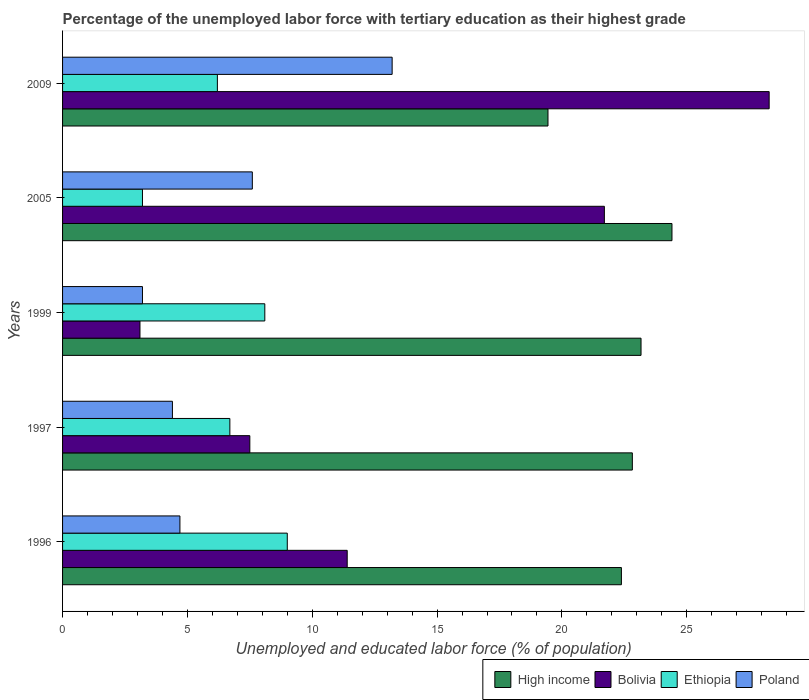Are the number of bars on each tick of the Y-axis equal?
Your response must be concise. Yes. How many bars are there on the 1st tick from the top?
Your answer should be very brief. 4. What is the percentage of the unemployed labor force with tertiary education in Bolivia in 1997?
Your response must be concise. 7.5. Across all years, what is the maximum percentage of the unemployed labor force with tertiary education in Bolivia?
Your answer should be compact. 28.3. Across all years, what is the minimum percentage of the unemployed labor force with tertiary education in Ethiopia?
Provide a succinct answer. 3.2. In which year was the percentage of the unemployed labor force with tertiary education in Ethiopia maximum?
Offer a terse response. 1996. What is the total percentage of the unemployed labor force with tertiary education in Ethiopia in the graph?
Give a very brief answer. 33.2. What is the difference between the percentage of the unemployed labor force with tertiary education in Poland in 1996 and that in 2005?
Your response must be concise. -2.9. What is the difference between the percentage of the unemployed labor force with tertiary education in Poland in 2005 and the percentage of the unemployed labor force with tertiary education in Bolivia in 1997?
Offer a terse response. 0.1. What is the average percentage of the unemployed labor force with tertiary education in Poland per year?
Provide a succinct answer. 6.62. In the year 1997, what is the difference between the percentage of the unemployed labor force with tertiary education in Bolivia and percentage of the unemployed labor force with tertiary education in Poland?
Offer a very short reply. 3.1. In how many years, is the percentage of the unemployed labor force with tertiary education in Poland greater than 6 %?
Offer a terse response. 2. What is the ratio of the percentage of the unemployed labor force with tertiary education in Bolivia in 1996 to that in 1997?
Offer a terse response. 1.52. Is the difference between the percentage of the unemployed labor force with tertiary education in Bolivia in 1996 and 2009 greater than the difference between the percentage of the unemployed labor force with tertiary education in Poland in 1996 and 2009?
Your answer should be very brief. No. What is the difference between the highest and the second highest percentage of the unemployed labor force with tertiary education in Bolivia?
Your answer should be compact. 6.6. What is the difference between the highest and the lowest percentage of the unemployed labor force with tertiary education in Poland?
Provide a succinct answer. 10. Is the sum of the percentage of the unemployed labor force with tertiary education in Poland in 1996 and 1997 greater than the maximum percentage of the unemployed labor force with tertiary education in High income across all years?
Your answer should be compact. No. What does the 2nd bar from the bottom in 2005 represents?
Keep it short and to the point. Bolivia. Is it the case that in every year, the sum of the percentage of the unemployed labor force with tertiary education in Poland and percentage of the unemployed labor force with tertiary education in High income is greater than the percentage of the unemployed labor force with tertiary education in Bolivia?
Provide a succinct answer. Yes. How many bars are there?
Keep it short and to the point. 20. Are the values on the major ticks of X-axis written in scientific E-notation?
Provide a short and direct response. No. Does the graph contain grids?
Keep it short and to the point. No. Where does the legend appear in the graph?
Offer a very short reply. Bottom right. How many legend labels are there?
Ensure brevity in your answer.  4. What is the title of the graph?
Make the answer very short. Percentage of the unemployed labor force with tertiary education as their highest grade. What is the label or title of the X-axis?
Give a very brief answer. Unemployed and educated labor force (% of population). What is the label or title of the Y-axis?
Your answer should be very brief. Years. What is the Unemployed and educated labor force (% of population) of High income in 1996?
Your response must be concise. 22.38. What is the Unemployed and educated labor force (% of population) in Bolivia in 1996?
Make the answer very short. 11.4. What is the Unemployed and educated labor force (% of population) of Poland in 1996?
Provide a succinct answer. 4.7. What is the Unemployed and educated labor force (% of population) of High income in 1997?
Provide a short and direct response. 22.82. What is the Unemployed and educated labor force (% of population) of Bolivia in 1997?
Provide a succinct answer. 7.5. What is the Unemployed and educated labor force (% of population) in Ethiopia in 1997?
Your answer should be compact. 6.7. What is the Unemployed and educated labor force (% of population) in Poland in 1997?
Ensure brevity in your answer.  4.4. What is the Unemployed and educated labor force (% of population) in High income in 1999?
Provide a short and direct response. 23.17. What is the Unemployed and educated labor force (% of population) in Bolivia in 1999?
Provide a succinct answer. 3.1. What is the Unemployed and educated labor force (% of population) in Ethiopia in 1999?
Give a very brief answer. 8.1. What is the Unemployed and educated labor force (% of population) of Poland in 1999?
Provide a succinct answer. 3.2. What is the Unemployed and educated labor force (% of population) in High income in 2005?
Make the answer very short. 24.41. What is the Unemployed and educated labor force (% of population) of Bolivia in 2005?
Give a very brief answer. 21.7. What is the Unemployed and educated labor force (% of population) of Ethiopia in 2005?
Offer a terse response. 3.2. What is the Unemployed and educated labor force (% of population) in Poland in 2005?
Offer a very short reply. 7.6. What is the Unemployed and educated labor force (% of population) of High income in 2009?
Offer a very short reply. 19.44. What is the Unemployed and educated labor force (% of population) in Bolivia in 2009?
Give a very brief answer. 28.3. What is the Unemployed and educated labor force (% of population) in Ethiopia in 2009?
Provide a succinct answer. 6.2. What is the Unemployed and educated labor force (% of population) in Poland in 2009?
Ensure brevity in your answer.  13.2. Across all years, what is the maximum Unemployed and educated labor force (% of population) in High income?
Provide a succinct answer. 24.41. Across all years, what is the maximum Unemployed and educated labor force (% of population) of Bolivia?
Offer a very short reply. 28.3. Across all years, what is the maximum Unemployed and educated labor force (% of population) of Ethiopia?
Give a very brief answer. 9. Across all years, what is the maximum Unemployed and educated labor force (% of population) of Poland?
Ensure brevity in your answer.  13.2. Across all years, what is the minimum Unemployed and educated labor force (% of population) of High income?
Your answer should be compact. 19.44. Across all years, what is the minimum Unemployed and educated labor force (% of population) in Bolivia?
Offer a very short reply. 3.1. Across all years, what is the minimum Unemployed and educated labor force (% of population) in Ethiopia?
Your answer should be very brief. 3.2. Across all years, what is the minimum Unemployed and educated labor force (% of population) of Poland?
Keep it short and to the point. 3.2. What is the total Unemployed and educated labor force (% of population) of High income in the graph?
Offer a terse response. 112.22. What is the total Unemployed and educated labor force (% of population) in Ethiopia in the graph?
Give a very brief answer. 33.2. What is the total Unemployed and educated labor force (% of population) in Poland in the graph?
Keep it short and to the point. 33.1. What is the difference between the Unemployed and educated labor force (% of population) of High income in 1996 and that in 1997?
Your answer should be compact. -0.44. What is the difference between the Unemployed and educated labor force (% of population) of Ethiopia in 1996 and that in 1997?
Give a very brief answer. 2.3. What is the difference between the Unemployed and educated labor force (% of population) in High income in 1996 and that in 1999?
Offer a terse response. -0.79. What is the difference between the Unemployed and educated labor force (% of population) of Poland in 1996 and that in 1999?
Offer a very short reply. 1.5. What is the difference between the Unemployed and educated labor force (% of population) of High income in 1996 and that in 2005?
Your answer should be compact. -2.03. What is the difference between the Unemployed and educated labor force (% of population) in High income in 1996 and that in 2009?
Keep it short and to the point. 2.94. What is the difference between the Unemployed and educated labor force (% of population) of Bolivia in 1996 and that in 2009?
Make the answer very short. -16.9. What is the difference between the Unemployed and educated labor force (% of population) of Ethiopia in 1996 and that in 2009?
Offer a very short reply. 2.8. What is the difference between the Unemployed and educated labor force (% of population) in High income in 1997 and that in 1999?
Ensure brevity in your answer.  -0.35. What is the difference between the Unemployed and educated labor force (% of population) in Ethiopia in 1997 and that in 1999?
Give a very brief answer. -1.4. What is the difference between the Unemployed and educated labor force (% of population) of Poland in 1997 and that in 1999?
Give a very brief answer. 1.2. What is the difference between the Unemployed and educated labor force (% of population) of High income in 1997 and that in 2005?
Give a very brief answer. -1.59. What is the difference between the Unemployed and educated labor force (% of population) in Bolivia in 1997 and that in 2005?
Your answer should be very brief. -14.2. What is the difference between the Unemployed and educated labor force (% of population) of Poland in 1997 and that in 2005?
Your response must be concise. -3.2. What is the difference between the Unemployed and educated labor force (% of population) in High income in 1997 and that in 2009?
Keep it short and to the point. 3.38. What is the difference between the Unemployed and educated labor force (% of population) of Bolivia in 1997 and that in 2009?
Provide a succinct answer. -20.8. What is the difference between the Unemployed and educated labor force (% of population) in High income in 1999 and that in 2005?
Offer a very short reply. -1.24. What is the difference between the Unemployed and educated labor force (% of population) of Bolivia in 1999 and that in 2005?
Offer a very short reply. -18.6. What is the difference between the Unemployed and educated labor force (% of population) of Ethiopia in 1999 and that in 2005?
Ensure brevity in your answer.  4.9. What is the difference between the Unemployed and educated labor force (% of population) of High income in 1999 and that in 2009?
Provide a succinct answer. 3.73. What is the difference between the Unemployed and educated labor force (% of population) of Bolivia in 1999 and that in 2009?
Ensure brevity in your answer.  -25.2. What is the difference between the Unemployed and educated labor force (% of population) in Ethiopia in 1999 and that in 2009?
Your answer should be compact. 1.9. What is the difference between the Unemployed and educated labor force (% of population) in Poland in 1999 and that in 2009?
Keep it short and to the point. -10. What is the difference between the Unemployed and educated labor force (% of population) in High income in 2005 and that in 2009?
Offer a very short reply. 4.97. What is the difference between the Unemployed and educated labor force (% of population) of Ethiopia in 2005 and that in 2009?
Keep it short and to the point. -3. What is the difference between the Unemployed and educated labor force (% of population) in High income in 1996 and the Unemployed and educated labor force (% of population) in Bolivia in 1997?
Ensure brevity in your answer.  14.88. What is the difference between the Unemployed and educated labor force (% of population) of High income in 1996 and the Unemployed and educated labor force (% of population) of Ethiopia in 1997?
Offer a very short reply. 15.68. What is the difference between the Unemployed and educated labor force (% of population) of High income in 1996 and the Unemployed and educated labor force (% of population) of Poland in 1997?
Ensure brevity in your answer.  17.98. What is the difference between the Unemployed and educated labor force (% of population) in Ethiopia in 1996 and the Unemployed and educated labor force (% of population) in Poland in 1997?
Make the answer very short. 4.6. What is the difference between the Unemployed and educated labor force (% of population) in High income in 1996 and the Unemployed and educated labor force (% of population) in Bolivia in 1999?
Provide a short and direct response. 19.28. What is the difference between the Unemployed and educated labor force (% of population) in High income in 1996 and the Unemployed and educated labor force (% of population) in Ethiopia in 1999?
Your response must be concise. 14.28. What is the difference between the Unemployed and educated labor force (% of population) in High income in 1996 and the Unemployed and educated labor force (% of population) in Poland in 1999?
Provide a succinct answer. 19.18. What is the difference between the Unemployed and educated labor force (% of population) in Bolivia in 1996 and the Unemployed and educated labor force (% of population) in Poland in 1999?
Your answer should be compact. 8.2. What is the difference between the Unemployed and educated labor force (% of population) of High income in 1996 and the Unemployed and educated labor force (% of population) of Bolivia in 2005?
Make the answer very short. 0.68. What is the difference between the Unemployed and educated labor force (% of population) of High income in 1996 and the Unemployed and educated labor force (% of population) of Ethiopia in 2005?
Offer a very short reply. 19.18. What is the difference between the Unemployed and educated labor force (% of population) of High income in 1996 and the Unemployed and educated labor force (% of population) of Poland in 2005?
Ensure brevity in your answer.  14.78. What is the difference between the Unemployed and educated labor force (% of population) in Bolivia in 1996 and the Unemployed and educated labor force (% of population) in Ethiopia in 2005?
Your response must be concise. 8.2. What is the difference between the Unemployed and educated labor force (% of population) in High income in 1996 and the Unemployed and educated labor force (% of population) in Bolivia in 2009?
Give a very brief answer. -5.92. What is the difference between the Unemployed and educated labor force (% of population) of High income in 1996 and the Unemployed and educated labor force (% of population) of Ethiopia in 2009?
Keep it short and to the point. 16.18. What is the difference between the Unemployed and educated labor force (% of population) in High income in 1996 and the Unemployed and educated labor force (% of population) in Poland in 2009?
Keep it short and to the point. 9.18. What is the difference between the Unemployed and educated labor force (% of population) in Ethiopia in 1996 and the Unemployed and educated labor force (% of population) in Poland in 2009?
Provide a short and direct response. -4.2. What is the difference between the Unemployed and educated labor force (% of population) of High income in 1997 and the Unemployed and educated labor force (% of population) of Bolivia in 1999?
Your response must be concise. 19.72. What is the difference between the Unemployed and educated labor force (% of population) in High income in 1997 and the Unemployed and educated labor force (% of population) in Ethiopia in 1999?
Keep it short and to the point. 14.72. What is the difference between the Unemployed and educated labor force (% of population) in High income in 1997 and the Unemployed and educated labor force (% of population) in Poland in 1999?
Your response must be concise. 19.62. What is the difference between the Unemployed and educated labor force (% of population) of Bolivia in 1997 and the Unemployed and educated labor force (% of population) of Ethiopia in 1999?
Your response must be concise. -0.6. What is the difference between the Unemployed and educated labor force (% of population) in Ethiopia in 1997 and the Unemployed and educated labor force (% of population) in Poland in 1999?
Offer a terse response. 3.5. What is the difference between the Unemployed and educated labor force (% of population) of High income in 1997 and the Unemployed and educated labor force (% of population) of Bolivia in 2005?
Provide a succinct answer. 1.12. What is the difference between the Unemployed and educated labor force (% of population) of High income in 1997 and the Unemployed and educated labor force (% of population) of Ethiopia in 2005?
Give a very brief answer. 19.62. What is the difference between the Unemployed and educated labor force (% of population) of High income in 1997 and the Unemployed and educated labor force (% of population) of Poland in 2005?
Give a very brief answer. 15.22. What is the difference between the Unemployed and educated labor force (% of population) in Bolivia in 1997 and the Unemployed and educated labor force (% of population) in Poland in 2005?
Your answer should be very brief. -0.1. What is the difference between the Unemployed and educated labor force (% of population) in High income in 1997 and the Unemployed and educated labor force (% of population) in Bolivia in 2009?
Make the answer very short. -5.48. What is the difference between the Unemployed and educated labor force (% of population) of High income in 1997 and the Unemployed and educated labor force (% of population) of Ethiopia in 2009?
Ensure brevity in your answer.  16.62. What is the difference between the Unemployed and educated labor force (% of population) in High income in 1997 and the Unemployed and educated labor force (% of population) in Poland in 2009?
Provide a succinct answer. 9.62. What is the difference between the Unemployed and educated labor force (% of population) in Bolivia in 1997 and the Unemployed and educated labor force (% of population) in Poland in 2009?
Ensure brevity in your answer.  -5.7. What is the difference between the Unemployed and educated labor force (% of population) of Ethiopia in 1997 and the Unemployed and educated labor force (% of population) of Poland in 2009?
Offer a very short reply. -6.5. What is the difference between the Unemployed and educated labor force (% of population) in High income in 1999 and the Unemployed and educated labor force (% of population) in Bolivia in 2005?
Offer a very short reply. 1.47. What is the difference between the Unemployed and educated labor force (% of population) of High income in 1999 and the Unemployed and educated labor force (% of population) of Ethiopia in 2005?
Your answer should be compact. 19.97. What is the difference between the Unemployed and educated labor force (% of population) of High income in 1999 and the Unemployed and educated labor force (% of population) of Poland in 2005?
Give a very brief answer. 15.57. What is the difference between the Unemployed and educated labor force (% of population) of Bolivia in 1999 and the Unemployed and educated labor force (% of population) of Ethiopia in 2005?
Ensure brevity in your answer.  -0.1. What is the difference between the Unemployed and educated labor force (% of population) of Bolivia in 1999 and the Unemployed and educated labor force (% of population) of Poland in 2005?
Make the answer very short. -4.5. What is the difference between the Unemployed and educated labor force (% of population) in High income in 1999 and the Unemployed and educated labor force (% of population) in Bolivia in 2009?
Give a very brief answer. -5.13. What is the difference between the Unemployed and educated labor force (% of population) of High income in 1999 and the Unemployed and educated labor force (% of population) of Ethiopia in 2009?
Provide a succinct answer. 16.97. What is the difference between the Unemployed and educated labor force (% of population) of High income in 1999 and the Unemployed and educated labor force (% of population) of Poland in 2009?
Offer a very short reply. 9.97. What is the difference between the Unemployed and educated labor force (% of population) of Bolivia in 1999 and the Unemployed and educated labor force (% of population) of Ethiopia in 2009?
Provide a short and direct response. -3.1. What is the difference between the Unemployed and educated labor force (% of population) of Ethiopia in 1999 and the Unemployed and educated labor force (% of population) of Poland in 2009?
Offer a very short reply. -5.1. What is the difference between the Unemployed and educated labor force (% of population) of High income in 2005 and the Unemployed and educated labor force (% of population) of Bolivia in 2009?
Your response must be concise. -3.89. What is the difference between the Unemployed and educated labor force (% of population) of High income in 2005 and the Unemployed and educated labor force (% of population) of Ethiopia in 2009?
Your answer should be very brief. 18.21. What is the difference between the Unemployed and educated labor force (% of population) in High income in 2005 and the Unemployed and educated labor force (% of population) in Poland in 2009?
Offer a very short reply. 11.21. What is the difference between the Unemployed and educated labor force (% of population) in Bolivia in 2005 and the Unemployed and educated labor force (% of population) in Ethiopia in 2009?
Your answer should be very brief. 15.5. What is the difference between the Unemployed and educated labor force (% of population) in Bolivia in 2005 and the Unemployed and educated labor force (% of population) in Poland in 2009?
Ensure brevity in your answer.  8.5. What is the average Unemployed and educated labor force (% of population) of High income per year?
Give a very brief answer. 22.44. What is the average Unemployed and educated labor force (% of population) in Ethiopia per year?
Provide a succinct answer. 6.64. What is the average Unemployed and educated labor force (% of population) of Poland per year?
Provide a succinct answer. 6.62. In the year 1996, what is the difference between the Unemployed and educated labor force (% of population) in High income and Unemployed and educated labor force (% of population) in Bolivia?
Make the answer very short. 10.98. In the year 1996, what is the difference between the Unemployed and educated labor force (% of population) in High income and Unemployed and educated labor force (% of population) in Ethiopia?
Make the answer very short. 13.38. In the year 1996, what is the difference between the Unemployed and educated labor force (% of population) in High income and Unemployed and educated labor force (% of population) in Poland?
Give a very brief answer. 17.68. In the year 1996, what is the difference between the Unemployed and educated labor force (% of population) of Bolivia and Unemployed and educated labor force (% of population) of Poland?
Offer a very short reply. 6.7. In the year 1996, what is the difference between the Unemployed and educated labor force (% of population) in Ethiopia and Unemployed and educated labor force (% of population) in Poland?
Give a very brief answer. 4.3. In the year 1997, what is the difference between the Unemployed and educated labor force (% of population) in High income and Unemployed and educated labor force (% of population) in Bolivia?
Your response must be concise. 15.32. In the year 1997, what is the difference between the Unemployed and educated labor force (% of population) in High income and Unemployed and educated labor force (% of population) in Ethiopia?
Offer a very short reply. 16.12. In the year 1997, what is the difference between the Unemployed and educated labor force (% of population) in High income and Unemployed and educated labor force (% of population) in Poland?
Your answer should be compact. 18.42. In the year 1997, what is the difference between the Unemployed and educated labor force (% of population) of Ethiopia and Unemployed and educated labor force (% of population) of Poland?
Provide a succinct answer. 2.3. In the year 1999, what is the difference between the Unemployed and educated labor force (% of population) of High income and Unemployed and educated labor force (% of population) of Bolivia?
Provide a short and direct response. 20.07. In the year 1999, what is the difference between the Unemployed and educated labor force (% of population) in High income and Unemployed and educated labor force (% of population) in Ethiopia?
Ensure brevity in your answer.  15.07. In the year 1999, what is the difference between the Unemployed and educated labor force (% of population) of High income and Unemployed and educated labor force (% of population) of Poland?
Your answer should be compact. 19.97. In the year 1999, what is the difference between the Unemployed and educated labor force (% of population) in Bolivia and Unemployed and educated labor force (% of population) in Poland?
Ensure brevity in your answer.  -0.1. In the year 1999, what is the difference between the Unemployed and educated labor force (% of population) in Ethiopia and Unemployed and educated labor force (% of population) in Poland?
Provide a short and direct response. 4.9. In the year 2005, what is the difference between the Unemployed and educated labor force (% of population) of High income and Unemployed and educated labor force (% of population) of Bolivia?
Provide a short and direct response. 2.71. In the year 2005, what is the difference between the Unemployed and educated labor force (% of population) in High income and Unemployed and educated labor force (% of population) in Ethiopia?
Ensure brevity in your answer.  21.21. In the year 2005, what is the difference between the Unemployed and educated labor force (% of population) in High income and Unemployed and educated labor force (% of population) in Poland?
Provide a short and direct response. 16.81. In the year 2005, what is the difference between the Unemployed and educated labor force (% of population) in Bolivia and Unemployed and educated labor force (% of population) in Poland?
Your answer should be compact. 14.1. In the year 2009, what is the difference between the Unemployed and educated labor force (% of population) of High income and Unemployed and educated labor force (% of population) of Bolivia?
Your response must be concise. -8.86. In the year 2009, what is the difference between the Unemployed and educated labor force (% of population) of High income and Unemployed and educated labor force (% of population) of Ethiopia?
Your answer should be very brief. 13.24. In the year 2009, what is the difference between the Unemployed and educated labor force (% of population) of High income and Unemployed and educated labor force (% of population) of Poland?
Provide a short and direct response. 6.24. In the year 2009, what is the difference between the Unemployed and educated labor force (% of population) of Bolivia and Unemployed and educated labor force (% of population) of Ethiopia?
Provide a succinct answer. 22.1. In the year 2009, what is the difference between the Unemployed and educated labor force (% of population) in Bolivia and Unemployed and educated labor force (% of population) in Poland?
Your response must be concise. 15.1. In the year 2009, what is the difference between the Unemployed and educated labor force (% of population) in Ethiopia and Unemployed and educated labor force (% of population) in Poland?
Your answer should be very brief. -7. What is the ratio of the Unemployed and educated labor force (% of population) in High income in 1996 to that in 1997?
Provide a succinct answer. 0.98. What is the ratio of the Unemployed and educated labor force (% of population) in Bolivia in 1996 to that in 1997?
Give a very brief answer. 1.52. What is the ratio of the Unemployed and educated labor force (% of population) of Ethiopia in 1996 to that in 1997?
Ensure brevity in your answer.  1.34. What is the ratio of the Unemployed and educated labor force (% of population) in Poland in 1996 to that in 1997?
Provide a succinct answer. 1.07. What is the ratio of the Unemployed and educated labor force (% of population) of High income in 1996 to that in 1999?
Give a very brief answer. 0.97. What is the ratio of the Unemployed and educated labor force (% of population) in Bolivia in 1996 to that in 1999?
Offer a very short reply. 3.68. What is the ratio of the Unemployed and educated labor force (% of population) of Ethiopia in 1996 to that in 1999?
Your response must be concise. 1.11. What is the ratio of the Unemployed and educated labor force (% of population) of Poland in 1996 to that in 1999?
Your answer should be compact. 1.47. What is the ratio of the Unemployed and educated labor force (% of population) of High income in 1996 to that in 2005?
Provide a short and direct response. 0.92. What is the ratio of the Unemployed and educated labor force (% of population) in Bolivia in 1996 to that in 2005?
Provide a succinct answer. 0.53. What is the ratio of the Unemployed and educated labor force (% of population) in Ethiopia in 1996 to that in 2005?
Offer a terse response. 2.81. What is the ratio of the Unemployed and educated labor force (% of population) of Poland in 1996 to that in 2005?
Your response must be concise. 0.62. What is the ratio of the Unemployed and educated labor force (% of population) of High income in 1996 to that in 2009?
Offer a very short reply. 1.15. What is the ratio of the Unemployed and educated labor force (% of population) in Bolivia in 1996 to that in 2009?
Your answer should be very brief. 0.4. What is the ratio of the Unemployed and educated labor force (% of population) of Ethiopia in 1996 to that in 2009?
Make the answer very short. 1.45. What is the ratio of the Unemployed and educated labor force (% of population) of Poland in 1996 to that in 2009?
Ensure brevity in your answer.  0.36. What is the ratio of the Unemployed and educated labor force (% of population) of Bolivia in 1997 to that in 1999?
Make the answer very short. 2.42. What is the ratio of the Unemployed and educated labor force (% of population) of Ethiopia in 1997 to that in 1999?
Make the answer very short. 0.83. What is the ratio of the Unemployed and educated labor force (% of population) of Poland in 1997 to that in 1999?
Your answer should be very brief. 1.38. What is the ratio of the Unemployed and educated labor force (% of population) of High income in 1997 to that in 2005?
Make the answer very short. 0.94. What is the ratio of the Unemployed and educated labor force (% of population) of Bolivia in 1997 to that in 2005?
Make the answer very short. 0.35. What is the ratio of the Unemployed and educated labor force (% of population) in Ethiopia in 1997 to that in 2005?
Offer a terse response. 2.09. What is the ratio of the Unemployed and educated labor force (% of population) in Poland in 1997 to that in 2005?
Your answer should be compact. 0.58. What is the ratio of the Unemployed and educated labor force (% of population) in High income in 1997 to that in 2009?
Your answer should be very brief. 1.17. What is the ratio of the Unemployed and educated labor force (% of population) in Bolivia in 1997 to that in 2009?
Offer a very short reply. 0.27. What is the ratio of the Unemployed and educated labor force (% of population) of Ethiopia in 1997 to that in 2009?
Your response must be concise. 1.08. What is the ratio of the Unemployed and educated labor force (% of population) of Poland in 1997 to that in 2009?
Offer a terse response. 0.33. What is the ratio of the Unemployed and educated labor force (% of population) in High income in 1999 to that in 2005?
Offer a very short reply. 0.95. What is the ratio of the Unemployed and educated labor force (% of population) of Bolivia in 1999 to that in 2005?
Give a very brief answer. 0.14. What is the ratio of the Unemployed and educated labor force (% of population) of Ethiopia in 1999 to that in 2005?
Offer a terse response. 2.53. What is the ratio of the Unemployed and educated labor force (% of population) in Poland in 1999 to that in 2005?
Give a very brief answer. 0.42. What is the ratio of the Unemployed and educated labor force (% of population) in High income in 1999 to that in 2009?
Give a very brief answer. 1.19. What is the ratio of the Unemployed and educated labor force (% of population) in Bolivia in 1999 to that in 2009?
Keep it short and to the point. 0.11. What is the ratio of the Unemployed and educated labor force (% of population) in Ethiopia in 1999 to that in 2009?
Keep it short and to the point. 1.31. What is the ratio of the Unemployed and educated labor force (% of population) of Poland in 1999 to that in 2009?
Ensure brevity in your answer.  0.24. What is the ratio of the Unemployed and educated labor force (% of population) in High income in 2005 to that in 2009?
Ensure brevity in your answer.  1.26. What is the ratio of the Unemployed and educated labor force (% of population) in Bolivia in 2005 to that in 2009?
Offer a very short reply. 0.77. What is the ratio of the Unemployed and educated labor force (% of population) in Ethiopia in 2005 to that in 2009?
Provide a succinct answer. 0.52. What is the ratio of the Unemployed and educated labor force (% of population) in Poland in 2005 to that in 2009?
Make the answer very short. 0.58. What is the difference between the highest and the second highest Unemployed and educated labor force (% of population) in High income?
Your answer should be very brief. 1.24. What is the difference between the highest and the second highest Unemployed and educated labor force (% of population) in Ethiopia?
Your answer should be very brief. 0.9. What is the difference between the highest and the second highest Unemployed and educated labor force (% of population) in Poland?
Offer a very short reply. 5.6. What is the difference between the highest and the lowest Unemployed and educated labor force (% of population) of High income?
Provide a short and direct response. 4.97. What is the difference between the highest and the lowest Unemployed and educated labor force (% of population) of Bolivia?
Offer a terse response. 25.2. What is the difference between the highest and the lowest Unemployed and educated labor force (% of population) of Ethiopia?
Keep it short and to the point. 5.8. What is the difference between the highest and the lowest Unemployed and educated labor force (% of population) of Poland?
Ensure brevity in your answer.  10. 